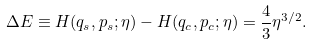Convert formula to latex. <formula><loc_0><loc_0><loc_500><loc_500>\Delta E \equiv H ( q _ { s } , p _ { s } ; \eta ) - H ( q _ { c } , p _ { c } ; \eta ) = \frac { 4 } { 3 } \eta ^ { 3 / 2 } .</formula> 